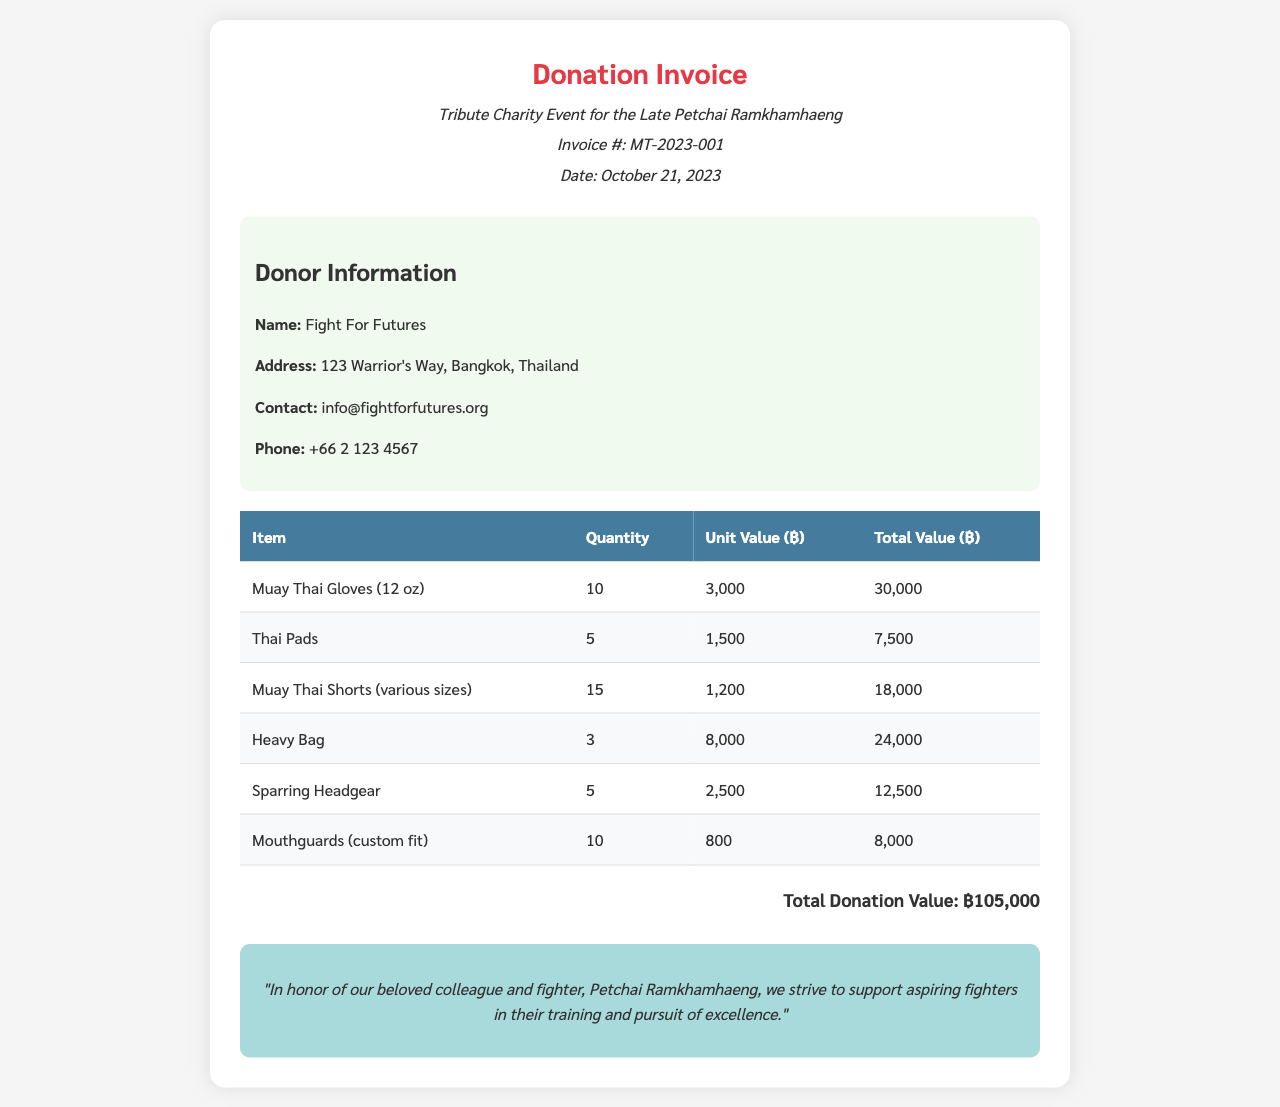What is the invoice number? The invoice number is located in the header under the title, indicating the specific invoice for the donation.
Answer: MT-2023-001 Who is the donor? The donor information is presented in a specific section, detailing the organization that made the contribution.
Answer: Fight For Futures What is the total donation value? The total donation value is calculated from the sum of all item totals listed in the document.
Answer: ฿105,000 What date was the invoice issued? The date of the invoice is mentioned in the header section of the document.
Answer: October 21, 2023 How many Muay Thai Gloves were donated? The quantity of Muay Thai Gloves is specified in the table detailing the donated items.
Answer: 10 What is the unit value of the Heavy Bag? The unit value is shown in the table alongside the item description and quantity.
Answer: 8,000 What is the total value of the Thai Pads? The total value can be found in the table where all items are tracked with their respective totals.
Answer: 7,500 What type of event is this invoice for? The invoice mentions the type of event in the title and the opening section, which honors a specific individual.
Answer: Tribute Charity Event What is the contact email for the donor? The contact email is provided in the donor information section of the invoice.
Answer: info@fightforfutures.org 